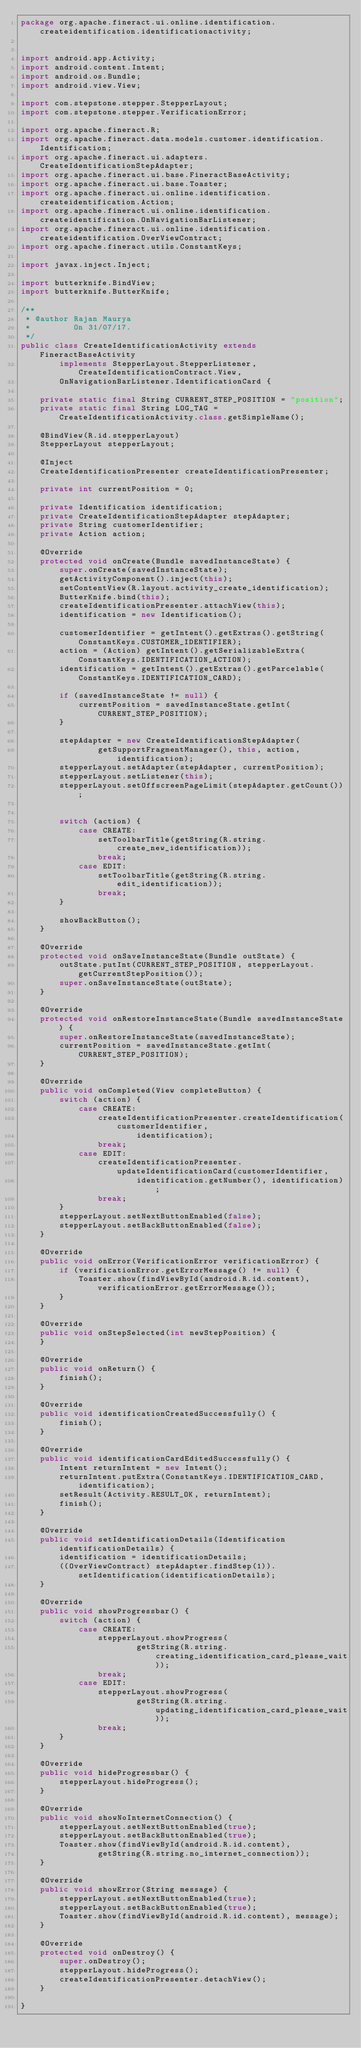Convert code to text. <code><loc_0><loc_0><loc_500><loc_500><_Java_>package org.apache.fineract.ui.online.identification.createidentification.identificationactivity;


import android.app.Activity;
import android.content.Intent;
import android.os.Bundle;
import android.view.View;

import com.stepstone.stepper.StepperLayout;
import com.stepstone.stepper.VerificationError;

import org.apache.fineract.R;
import org.apache.fineract.data.models.customer.identification.Identification;
import org.apache.fineract.ui.adapters.CreateIdentificationStepAdapter;
import org.apache.fineract.ui.base.FineractBaseActivity;
import org.apache.fineract.ui.base.Toaster;
import org.apache.fineract.ui.online.identification.createidentification.Action;
import org.apache.fineract.ui.online.identification.createidentification.OnNavigationBarListener;
import org.apache.fineract.ui.online.identification.createidentification.OverViewContract;
import org.apache.fineract.utils.ConstantKeys;

import javax.inject.Inject;

import butterknife.BindView;
import butterknife.ButterKnife;

/**
 * @author Rajan Maurya
 *         On 31/07/17.
 */
public class CreateIdentificationActivity extends FineractBaseActivity
        implements StepperLayout.StepperListener, CreateIdentificationContract.View,
        OnNavigationBarListener.IdentificationCard {

    private static final String CURRENT_STEP_POSITION = "position";
    private static final String LOG_TAG = CreateIdentificationActivity.class.getSimpleName();

    @BindView(R.id.stepperLayout)
    StepperLayout stepperLayout;

    @Inject
    CreateIdentificationPresenter createIdentificationPresenter;

    private int currentPosition = 0;

    private Identification identification;
    private CreateIdentificationStepAdapter stepAdapter;
    private String customerIdentifier;
    private Action action;

    @Override
    protected void onCreate(Bundle savedInstanceState) {
        super.onCreate(savedInstanceState);
        getActivityComponent().inject(this);
        setContentView(R.layout.activity_create_identification);
        ButterKnife.bind(this);
        createIdentificationPresenter.attachView(this);
        identification = new Identification();

        customerIdentifier = getIntent().getExtras().getString(ConstantKeys.CUSTOMER_IDENTIFIER);
        action = (Action) getIntent().getSerializableExtra(ConstantKeys.IDENTIFICATION_ACTION);
        identification = getIntent().getExtras().getParcelable(ConstantKeys.IDENTIFICATION_CARD);

        if (savedInstanceState != null) {
            currentPosition = savedInstanceState.getInt(CURRENT_STEP_POSITION);
        }

        stepAdapter = new CreateIdentificationStepAdapter(
                getSupportFragmentManager(), this, action, identification);
        stepperLayout.setAdapter(stepAdapter, currentPosition);
        stepperLayout.setListener(this);
        stepperLayout.setOffscreenPageLimit(stepAdapter.getCount());


        switch (action) {
            case CREATE:
                setToolbarTitle(getString(R.string.create_new_identification));
                break;
            case EDIT:
                setToolbarTitle(getString(R.string.edit_identification));
                break;
        }

        showBackButton();
    }

    @Override
    protected void onSaveInstanceState(Bundle outState) {
        outState.putInt(CURRENT_STEP_POSITION, stepperLayout.getCurrentStepPosition());
        super.onSaveInstanceState(outState);
    }

    @Override
    protected void onRestoreInstanceState(Bundle savedInstanceState) {
        super.onRestoreInstanceState(savedInstanceState);
        currentPosition = savedInstanceState.getInt(CURRENT_STEP_POSITION);
    }

    @Override
    public void onCompleted(View completeButton) {
        switch (action) {
            case CREATE:
                createIdentificationPresenter.createIdentification(customerIdentifier,
                        identification);
                break;
            case EDIT:
                createIdentificationPresenter.updateIdentificationCard(customerIdentifier,
                        identification.getNumber(), identification);
                break;
        }
        stepperLayout.setNextButtonEnabled(false);
        stepperLayout.setBackButtonEnabled(false);
    }

    @Override
    public void onError(VerificationError verificationError) {
        if (verificationError.getErrorMessage() != null) {
            Toaster.show(findViewById(android.R.id.content), verificationError.getErrorMessage());
        }
    }

    @Override
    public void onStepSelected(int newStepPosition) {
    }

    @Override
    public void onReturn() {
        finish();
    }

    @Override
    public void identificationCreatedSuccessfully() {
        finish();
    }

    @Override
    public void identificationCardEditedSuccessfully() {
        Intent returnIntent = new Intent();
        returnIntent.putExtra(ConstantKeys.IDENTIFICATION_CARD, identification);
        setResult(Activity.RESULT_OK, returnIntent);
        finish();
    }

    @Override
    public void setIdentificationDetails(Identification identificationDetails) {
        identification = identificationDetails;
        ((OverViewContract) stepAdapter.findStep(1)).setIdentification(identificationDetails);
    }

    @Override
    public void showProgressbar() {
        switch (action) {
            case CREATE:
                stepperLayout.showProgress(
                        getString(R.string.creating_identification_card_please_wait));
                break;
            case EDIT:
                stepperLayout.showProgress(
                        getString(R.string.updating_identification_card_please_wait));
                break;
        }
    }

    @Override
    public void hideProgressbar() {
        stepperLayout.hideProgress();
    }

    @Override
    public void showNoInternetConnection() {
        stepperLayout.setNextButtonEnabled(true);
        stepperLayout.setBackButtonEnabled(true);
        Toaster.show(findViewById(android.R.id.content),
                getString(R.string.no_internet_connection));
    }

    @Override
    public void showError(String message) {
        stepperLayout.setNextButtonEnabled(true);
        stepperLayout.setBackButtonEnabled(true);
        Toaster.show(findViewById(android.R.id.content), message);
    }

    @Override
    protected void onDestroy() {
        super.onDestroy();
        stepperLayout.hideProgress();
        createIdentificationPresenter.detachView();
    }

}
</code> 